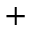Convert formula to latex. <formula><loc_0><loc_0><loc_500><loc_500>+</formula> 